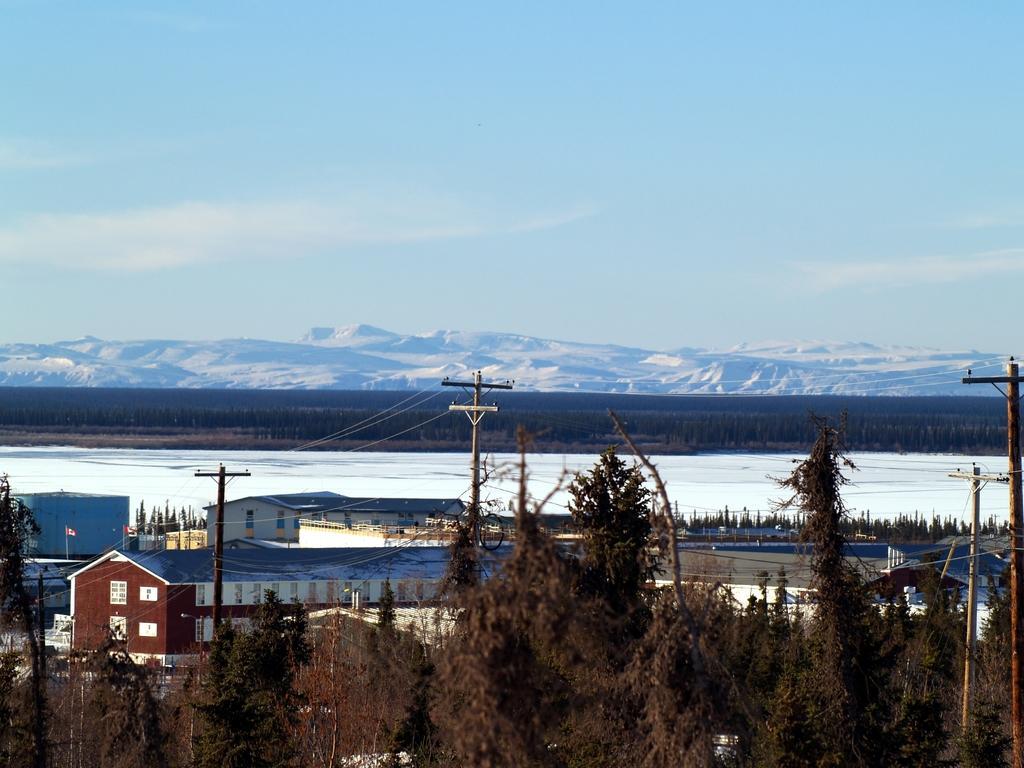Describe this image in one or two sentences. In this Image we can see a clear blue sky and snowy mountains over here. We can see that ground is covered with snow and there are few buildings over here and in between the buildings are 2 flags. There are 4 electrical poles and a lot of trees. 